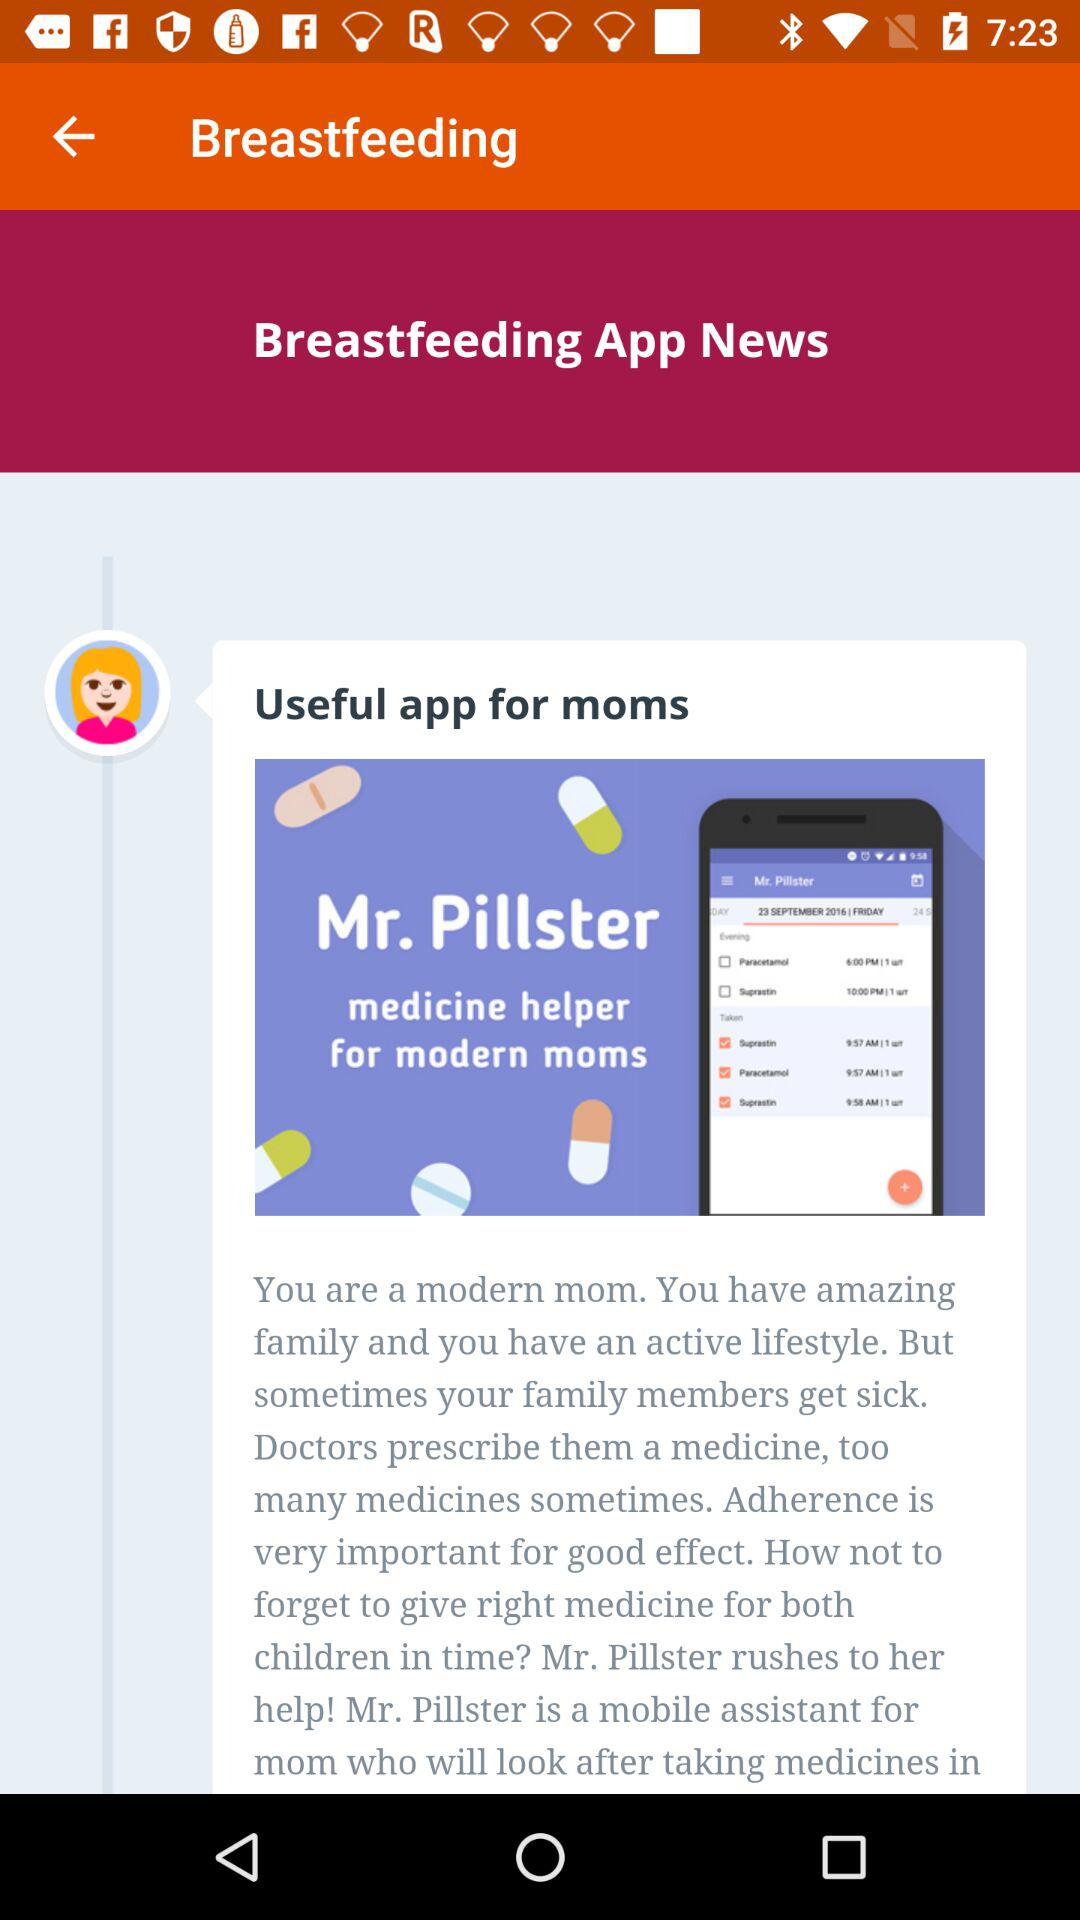What is the application name? The application name is "Breastfeeding". 